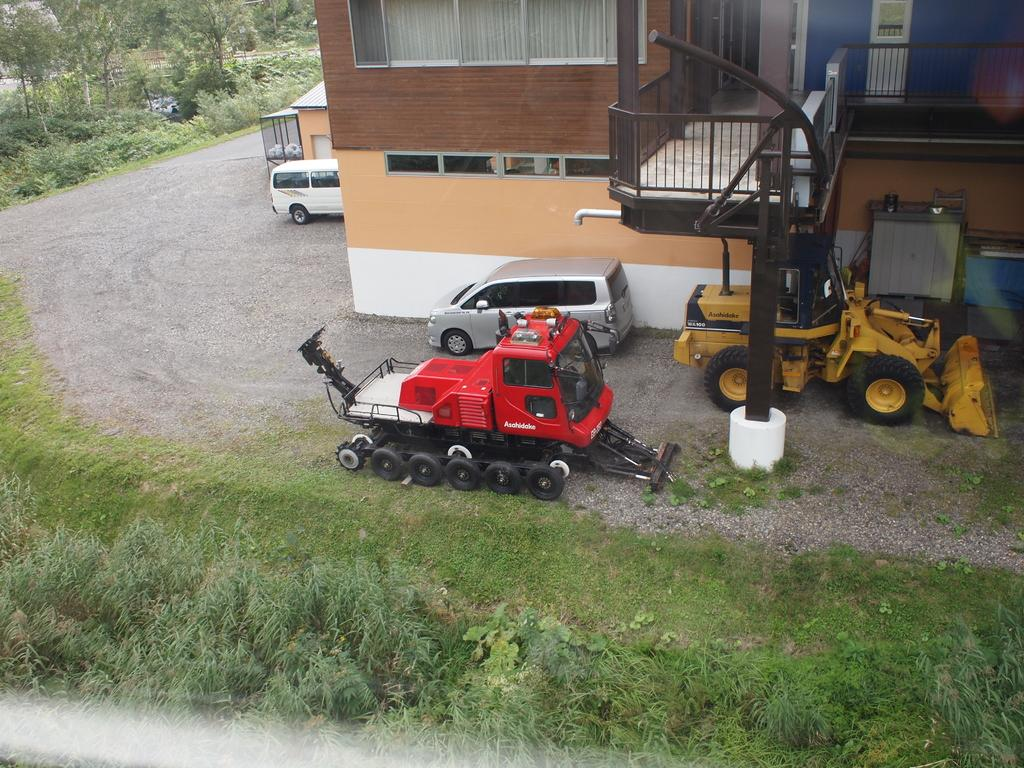What types of objects are present in the image? There are vehicles in the image. Can you describe one of the vehicles? One of the vehicles is red. What else can be seen in the image besides the vehicles? There is a building and trees in the image. What colors are visible on the building? The building has brown and cream colors. How would you describe the trees in the image? The trees have green colors. How many people are in the flock of birds flying over the seashore in the image? There is no flock of birds or seashore present in the image; it features vehicles, a building, and trees. 